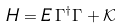<formula> <loc_0><loc_0><loc_500><loc_500>H = E \, \Gamma ^ { \dag } \Gamma + \mathcal { K }</formula> 